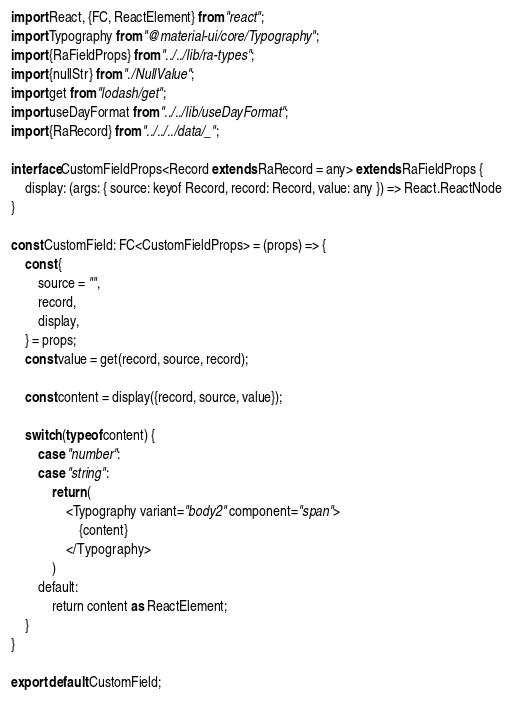Convert code to text. <code><loc_0><loc_0><loc_500><loc_500><_TypeScript_>import React, {FC, ReactElement} from "react";
import Typography from "@material-ui/core/Typography";
import {RaFieldProps} from "../../lib/ra-types";
import {nullStr} from "./NullValue";
import get from "lodash/get";
import useDayFormat from "../../lib/useDayFormat";
import {RaRecord} from "../../../data/_";

interface CustomFieldProps<Record extends RaRecord = any> extends RaFieldProps {
    display: (args: { source: keyof Record, record: Record, value: any }) => React.ReactNode
}

const CustomField: FC<CustomFieldProps> = (props) => {
    const {
        source = "",
        record,
        display,
    } = props;
    const value = get(record, source, record);

    const content = display({record, source, value});

    switch (typeof content) {
        case "number":
        case "string":
            return (
                <Typography variant="body2" component="span">
                    {content}
                </Typography>
            )
        default:
            return content as ReactElement;
    }
}

export default CustomField;</code> 